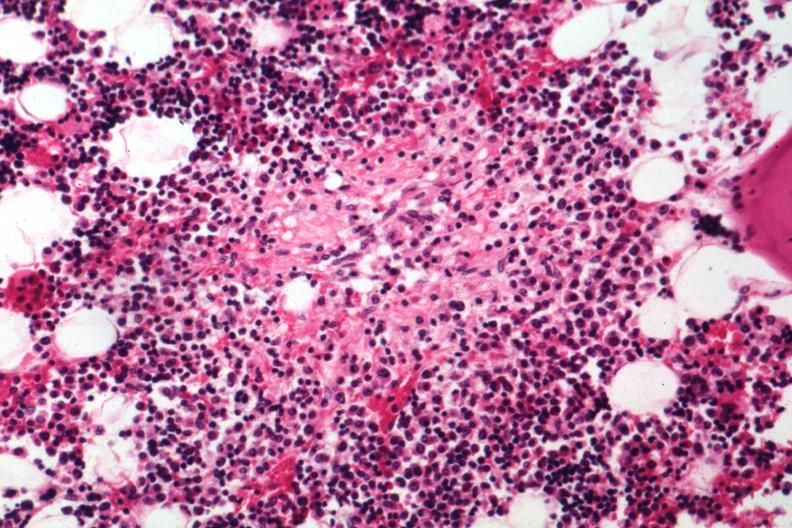s hematologic present?
Answer the question using a single word or phrase. Yes 